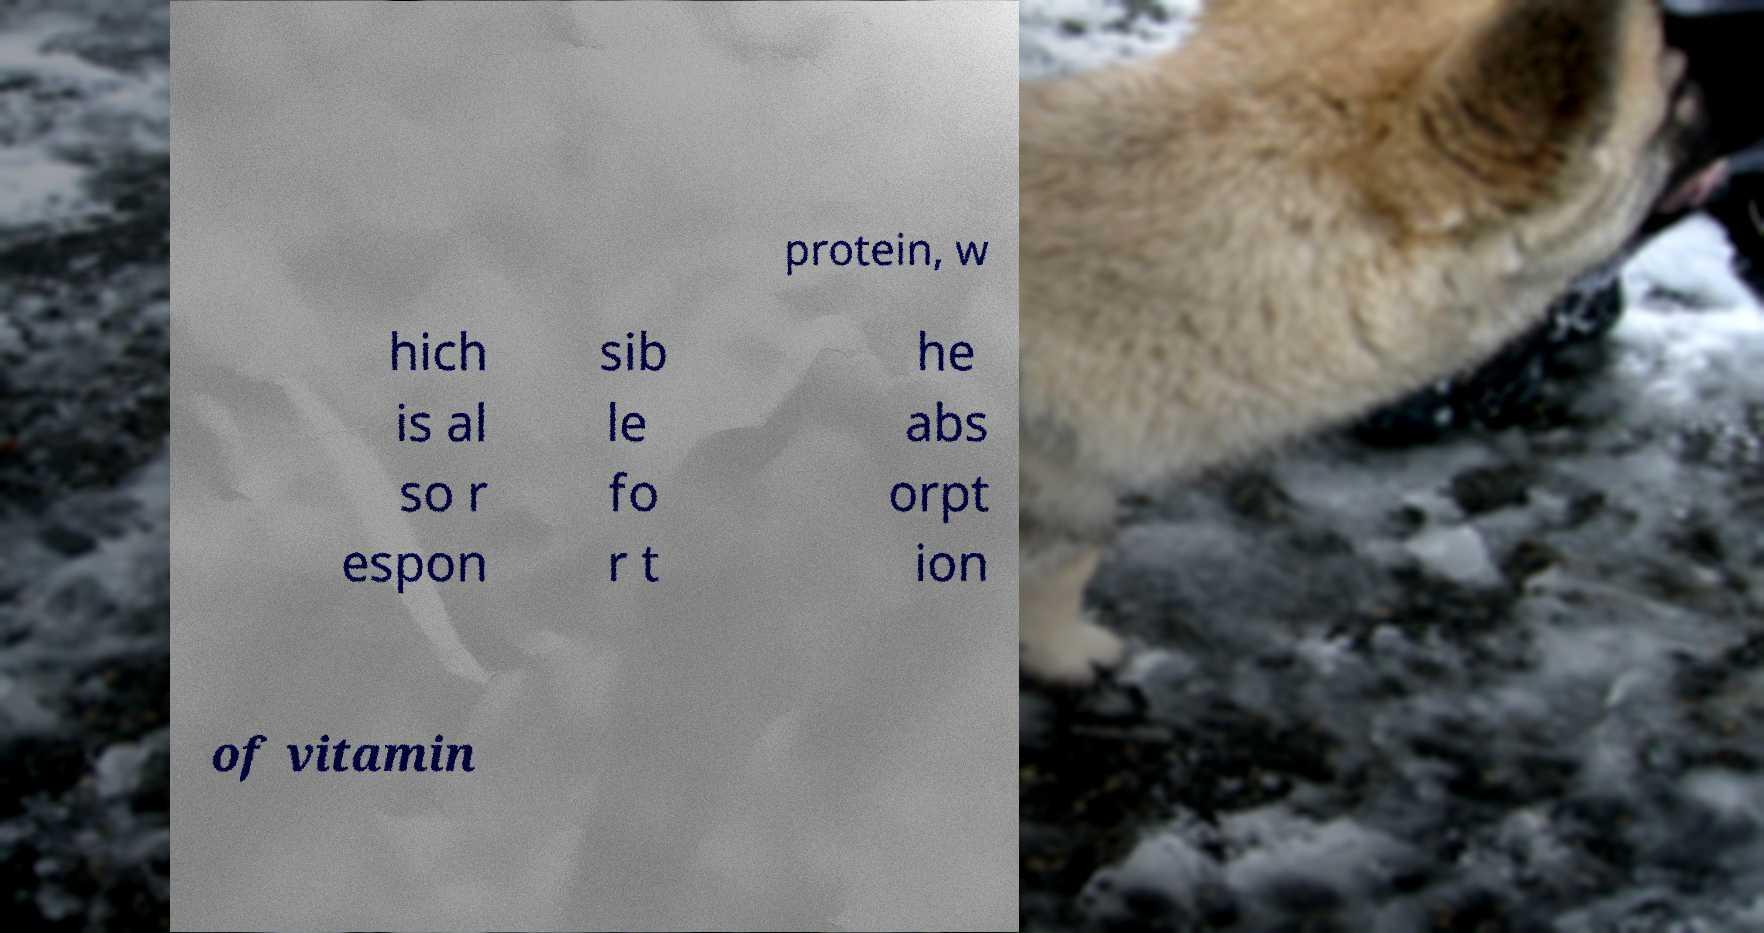Please identify and transcribe the text found in this image. protein, w hich is al so r espon sib le fo r t he abs orpt ion of vitamin 